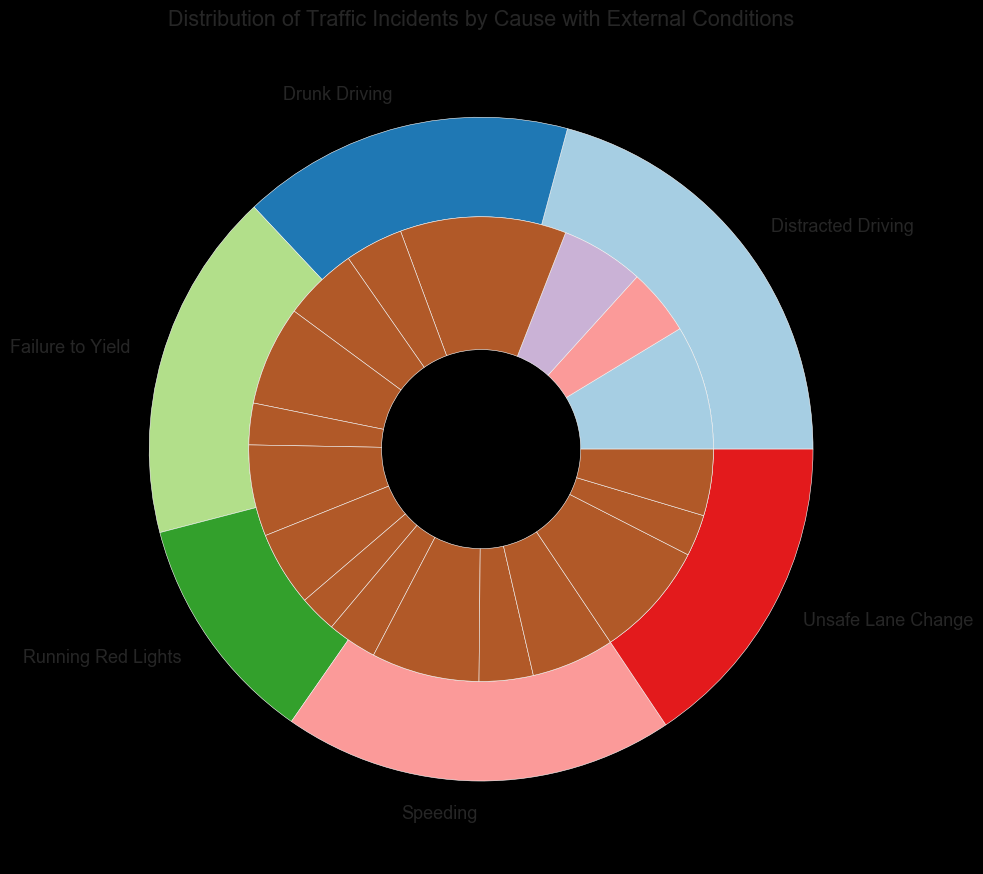What is the total number of traffic incidents caused by Drunk Driving? To find the total number of traffic incidents caused by Drunk Driving, we need to sum the incidents that occurred during Clear Day, Rainy Day, and Night. The incidents are 120 (Clear Day), 50 (Rainy Day), and 110 (Night). Summing these values: 120 + 50 + 110 = 280.
Answer: 280 Which cause of incidents has the highest number of incidents during Clear Day conditions? By examining the outer ring's labels and comparing the segments, we see that Distracted Driving has the largest segment in the Clear Day condition with 200 incidents.
Answer: Distracted Driving How many more incidents are caused by Speeding than by Unsafe Lane Change? We first find the total incidents for both causes. For Speeding: 150 (Clear Day) + 80 (Rainy Day) + 100 (Night) = 330. For Unsafe Lane Change: 140 (Clear Day) + 50 (Rainy Day) + 80 (Night) = 270. The difference is 330 - 270 = 60.
Answer: 60 What is the average number of incidents for Running Red Lights under all conditions? Sum the values for Running Red Lights: 90 (Clear Day), 45 (Rainy Day), and 60 (Night) which totals to 195. Dividing this total by the number of conditions (3): 195 / 3 = 65.
Answer: 65 Is the number of incidents due to Failure to Yield at Night greater than those due to Drunk Driving at Rainy Day? We compare the two values: Failure to Yield at Night has 100 incidents, while Drunk Driving at Rainy Day has 50 incidents. Since 100 is greater than 50, the answer is yes.
Answer: Yes Which external condition has the fewest incidents for the cause Speeding? For Speeding, the incidents for each condition are: 150 (Clear Day), 80 (Rainy Day), and 100 (Night). The fewest incidents occur during the Rainy Day condition with 80 incidents.
Answer: Rainy Day Compare the number of incidents due to Distracted Driving at Night to those due to Running Red Lights on a Clear Day. Which one is higher? Distracted Driving at Night has 90 incidents, and Running Red Lights on a Clear Day has 90 incidents as well. Since they are equal, neither is higher.
Answer: Equal What fraction of total incidents caused by Drunk Driving occur during the Night? Total incidents for Drunk Driving are 280. Incidents during the Night are 110. The fraction is 110 / 280. Simplifying, we divide both by their greatest common divisor (10): 11 / 28.
Answer: 11/28 If you were to combine the incidents of Speeding and Failure to Yield, what would be the total number of incidents during a Clear Day? Summing up the incidents during a Clear Day: Speeding has 150 and Failure to Yield has 130. Combined, they result in 150 + 130 = 280.
Answer: 280 